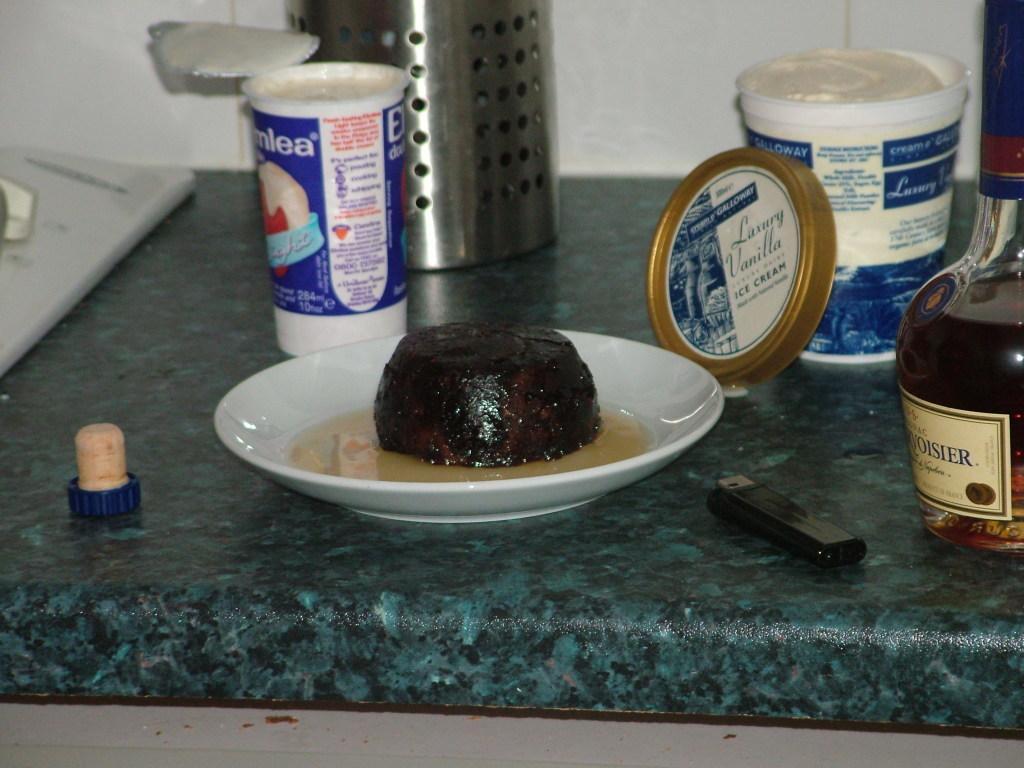Could you give a brief overview of what you see in this image? In the picture I can see some food item is kept on the white color plate, here I can see a bottle with a drink and a label on it, I can see tins and a few more objects are placed on the marble surface. In the background, I can see the wall. 